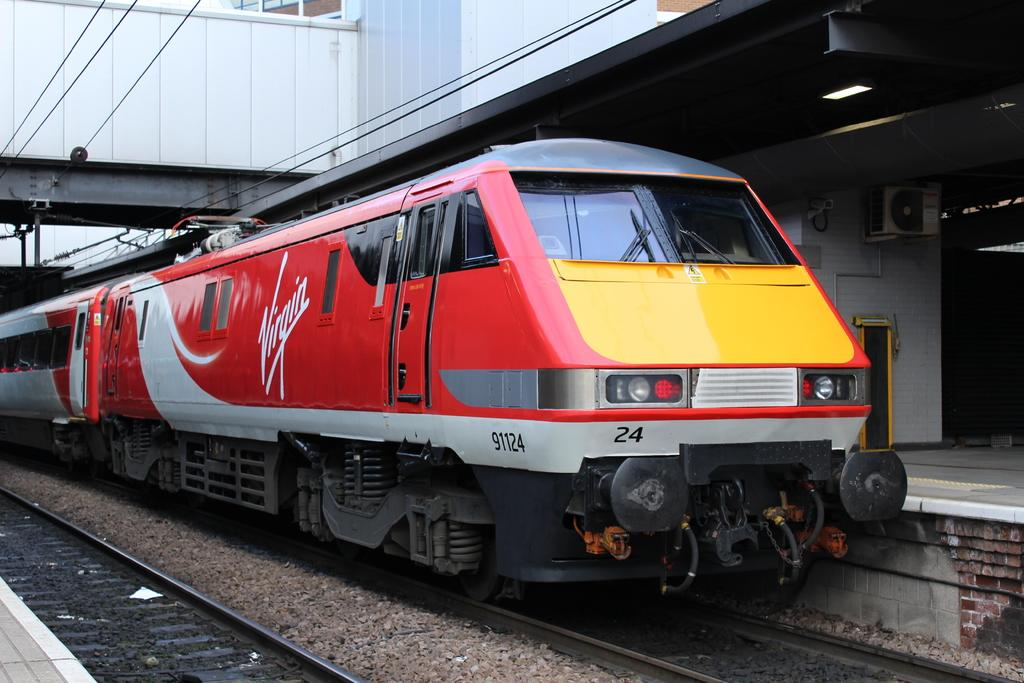What is the main subject of the image? The main subject of the image is a train. Where is the train located in the image? The train is on rail tracks in the image. What else can be seen in the image besides the train? There is a platform, a wall with doors, a roof with lights, lights, wires, and partially covered windows visible in the image. Where is the lunchroom located in the image? There is no lunchroom present in the image. What type of game is being played on the train in the image? There is no game being played on the train in the image. 